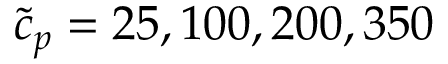Convert formula to latex. <formula><loc_0><loc_0><loc_500><loc_500>\tilde { c } _ { p } = 2 5 , 1 0 0 , 2 0 0 , 3 5 0</formula> 